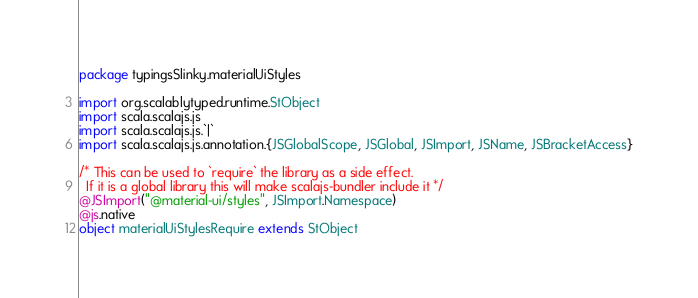<code> <loc_0><loc_0><loc_500><loc_500><_Scala_>package typingsSlinky.materialUiStyles

import org.scalablytyped.runtime.StObject
import scala.scalajs.js
import scala.scalajs.js.`|`
import scala.scalajs.js.annotation.{JSGlobalScope, JSGlobal, JSImport, JSName, JSBracketAccess}

/* This can be used to `require` the library as a side effect.
  If it is a global library this will make scalajs-bundler include it */
@JSImport("@material-ui/styles", JSImport.Namespace)
@js.native
object materialUiStylesRequire extends StObject
</code> 